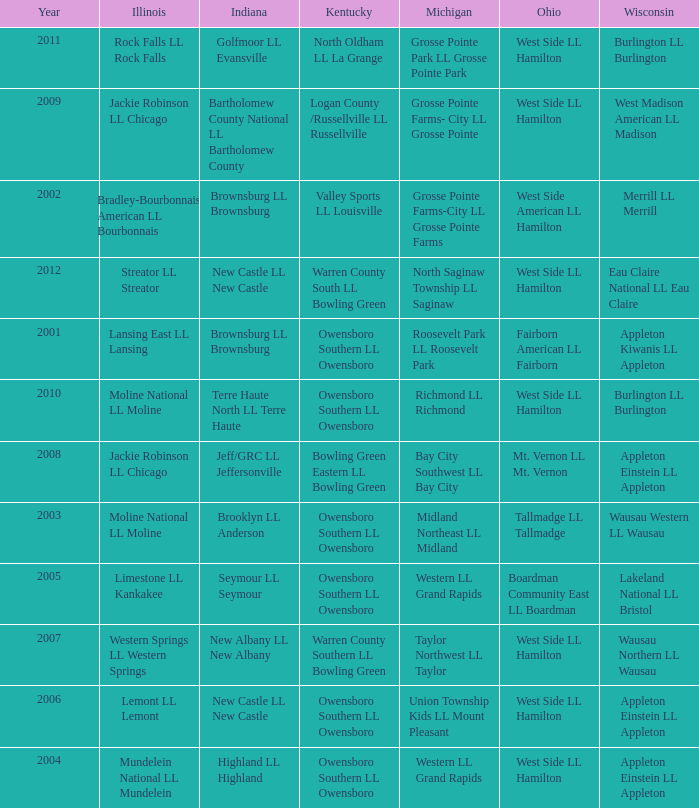What was the little league team from Kentucky when the little league team from Michigan was Grosse Pointe Farms-City LL Grosse Pointe Farms?  Valley Sports LL Louisville. 